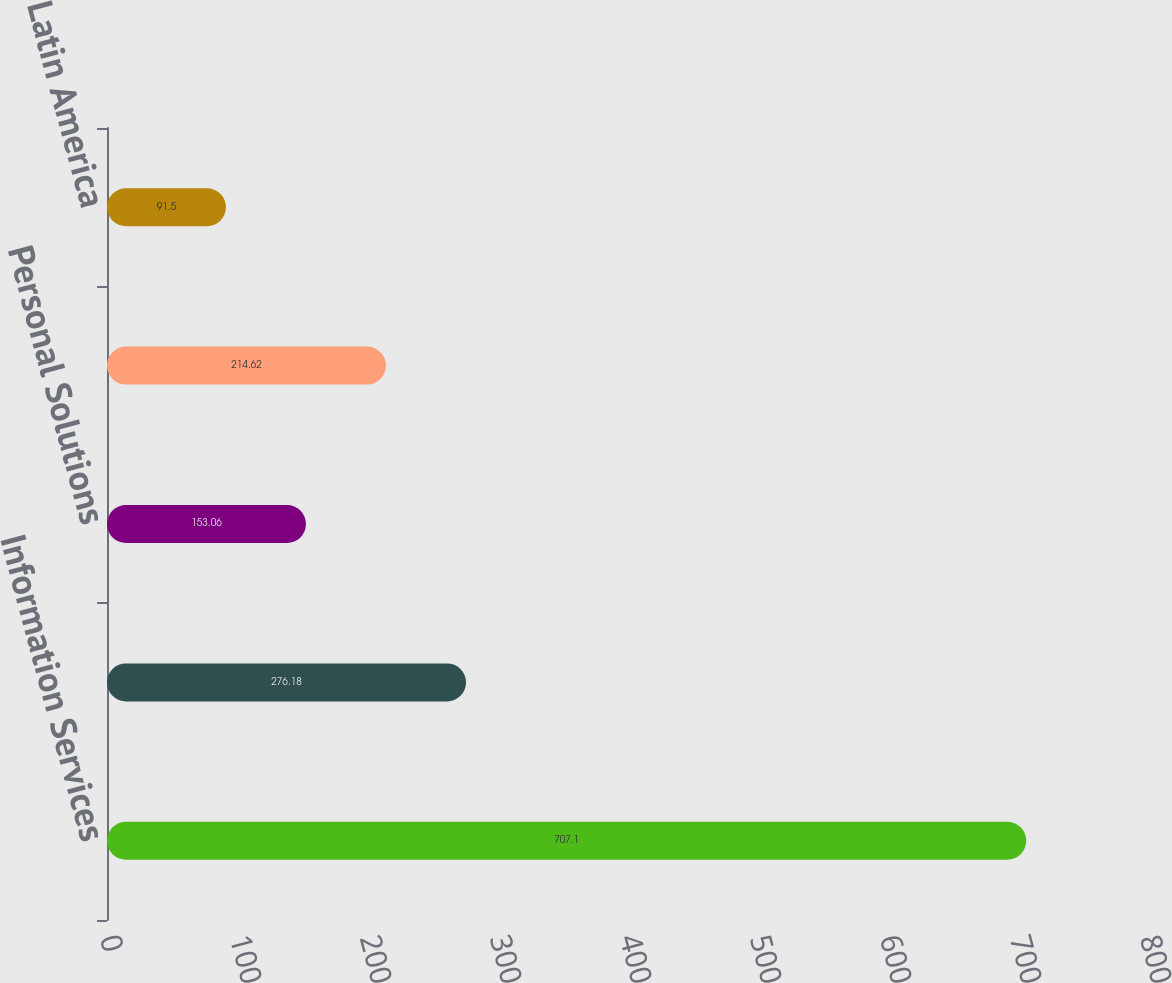Convert chart to OTSL. <chart><loc_0><loc_0><loc_500><loc_500><bar_chart><fcel>Information Services<fcel>Marketing Services<fcel>Personal Solutions<fcel>Europe<fcel>Latin America<nl><fcel>707.1<fcel>276.18<fcel>153.06<fcel>214.62<fcel>91.5<nl></chart> 